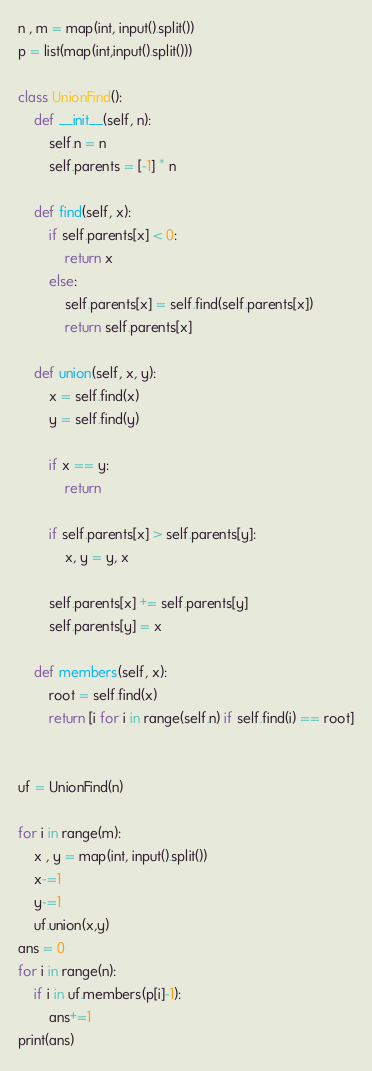<code> <loc_0><loc_0><loc_500><loc_500><_Python_>n , m = map(int, input().split())
p = list(map(int,input().split()))

class UnionFind():
    def __init__(self, n):
        self.n = n
        self.parents = [-1] * n

    def find(self, x):
        if self.parents[x] < 0:
            return x
        else:
            self.parents[x] = self.find(self.parents[x])
            return self.parents[x]

    def union(self, x, y):
        x = self.find(x)
        y = self.find(y)

        if x == y:
            return

        if self.parents[x] > self.parents[y]:
            x, y = y, x

        self.parents[x] += self.parents[y]
        self.parents[y] = x

    def members(self, x):
        root = self.find(x)
        return [i for i in range(self.n) if self.find(i) == root]


uf = UnionFind(n)

for i in range(m):
    x , y = map(int, input().split())
    x-=1
    y-=1
    uf.union(x,y)
ans = 0
for i in range(n):
    if i in uf.members(p[i]-1):
        ans+=1
print(ans)
</code> 